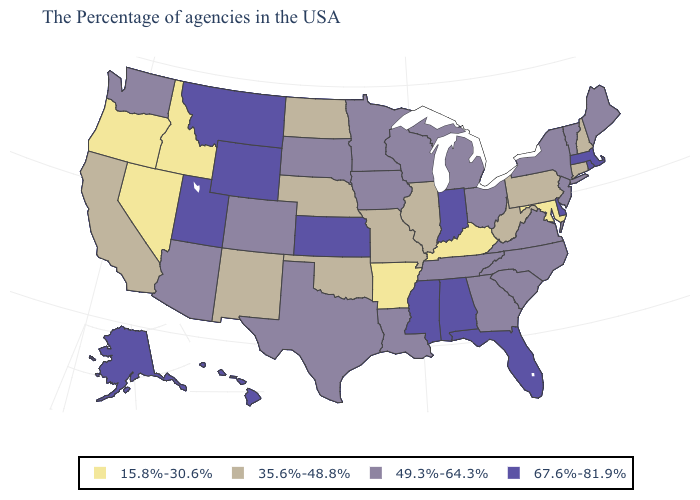Name the states that have a value in the range 67.6%-81.9%?
Write a very short answer. Massachusetts, Rhode Island, Delaware, Florida, Indiana, Alabama, Mississippi, Kansas, Wyoming, Utah, Montana, Alaska, Hawaii. What is the value of Tennessee?
Concise answer only. 49.3%-64.3%. Does Nevada have the lowest value in the USA?
Give a very brief answer. Yes. Does the map have missing data?
Short answer required. No. What is the value of Nebraska?
Answer briefly. 35.6%-48.8%. Is the legend a continuous bar?
Short answer required. No. Among the states that border Michigan , which have the lowest value?
Keep it brief. Ohio, Wisconsin. What is the value of Pennsylvania?
Be succinct. 35.6%-48.8%. What is the value of California?
Be succinct. 35.6%-48.8%. Does Arkansas have the same value as Ohio?
Write a very short answer. No. Does the map have missing data?
Be succinct. No. How many symbols are there in the legend?
Quick response, please. 4. Does Alabama have a higher value than Montana?
Short answer required. No. Does Maine have the lowest value in the Northeast?
Short answer required. No. 